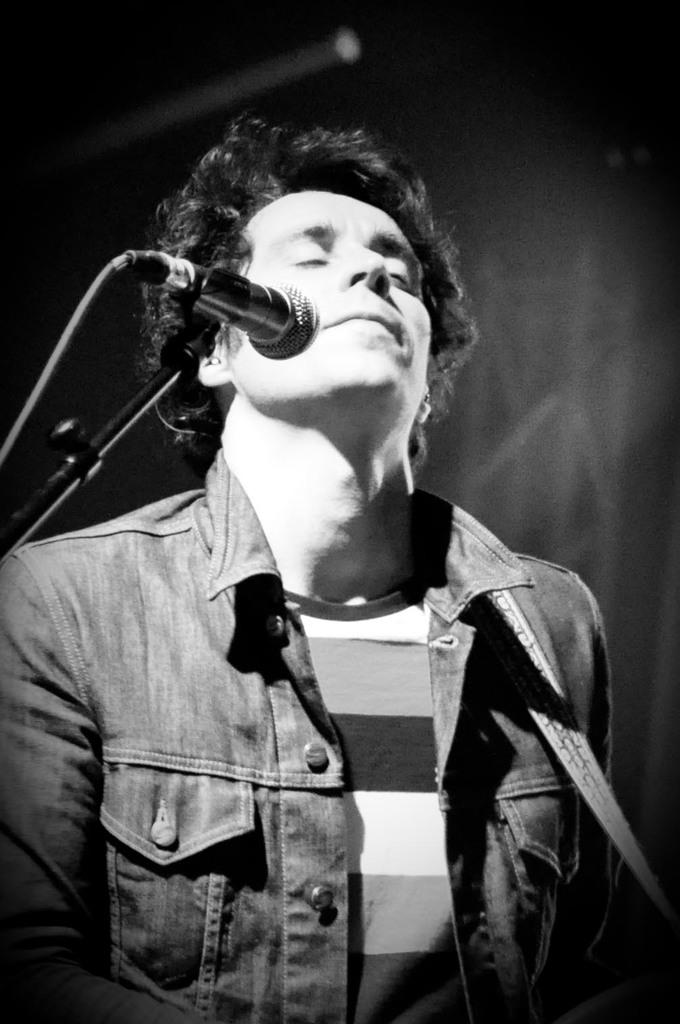What is the main subject of the image? The main subject of the image is a man. What is the man doing in the image? The man is standing in front of a microphone. What is the man's facial expression in the image? The man has his eyes closed. How many dolls are sitting on the letters in the image? There are no dolls or letters present in the image. 